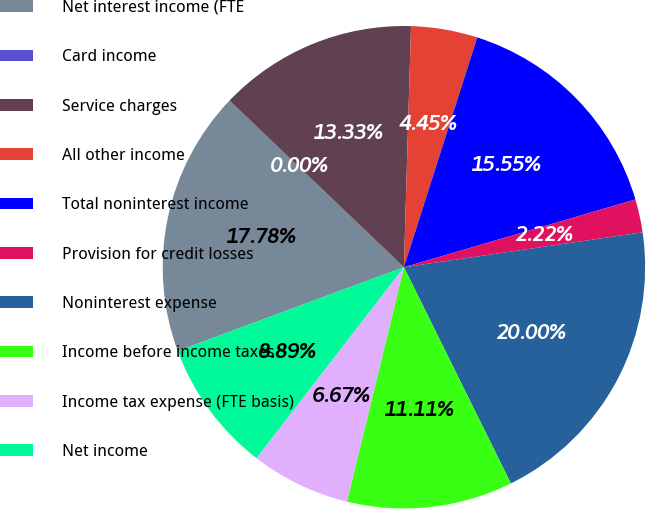<chart> <loc_0><loc_0><loc_500><loc_500><pie_chart><fcel>Net interest income (FTE<fcel>Card income<fcel>Service charges<fcel>All other income<fcel>Total noninterest income<fcel>Provision for credit losses<fcel>Noninterest expense<fcel>Income before income taxes<fcel>Income tax expense (FTE basis)<fcel>Net income<nl><fcel>17.78%<fcel>0.0%<fcel>13.33%<fcel>4.45%<fcel>15.55%<fcel>2.22%<fcel>20.0%<fcel>11.11%<fcel>6.67%<fcel>8.89%<nl></chart> 